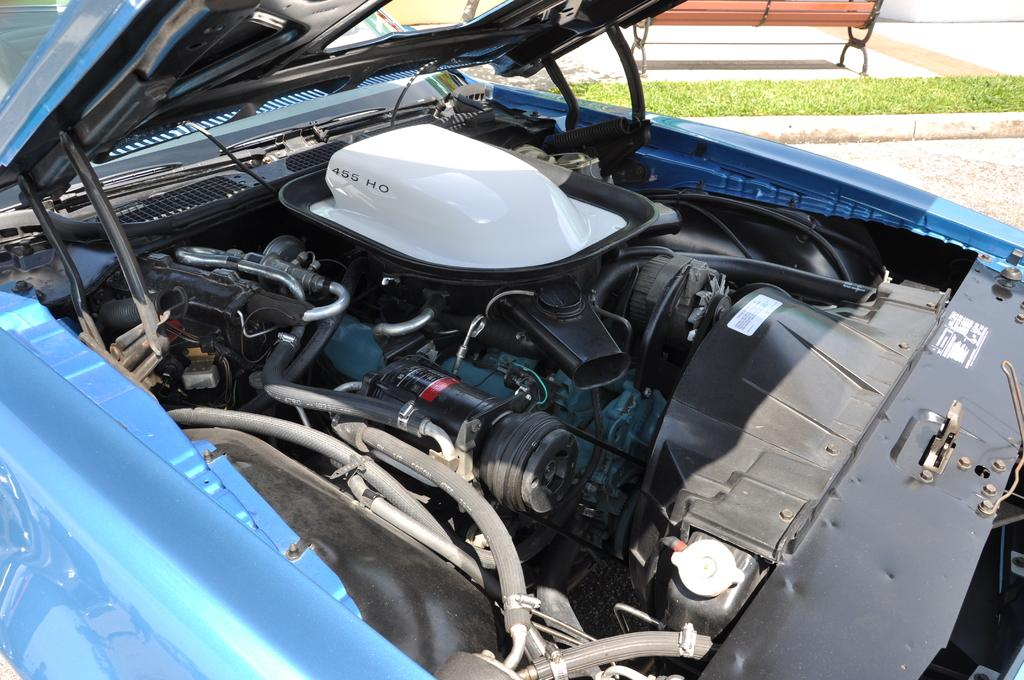What is the main subject of the image? The image shows internal parts of a car. What can be seen in the background of the image? There is a bench and grass in the background of the image. What type of voice can be heard coming from the queen in the image? There is no queen or voice present in the image; it shows internal parts of a car and a background with a bench and grass. 